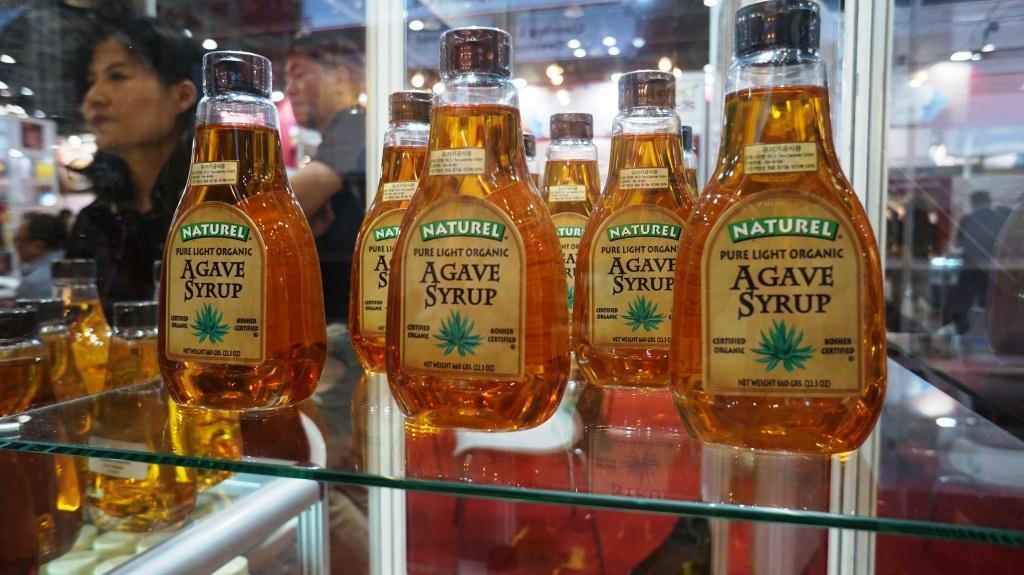Is this syrup natural or not?
Your response must be concise. Yes. 